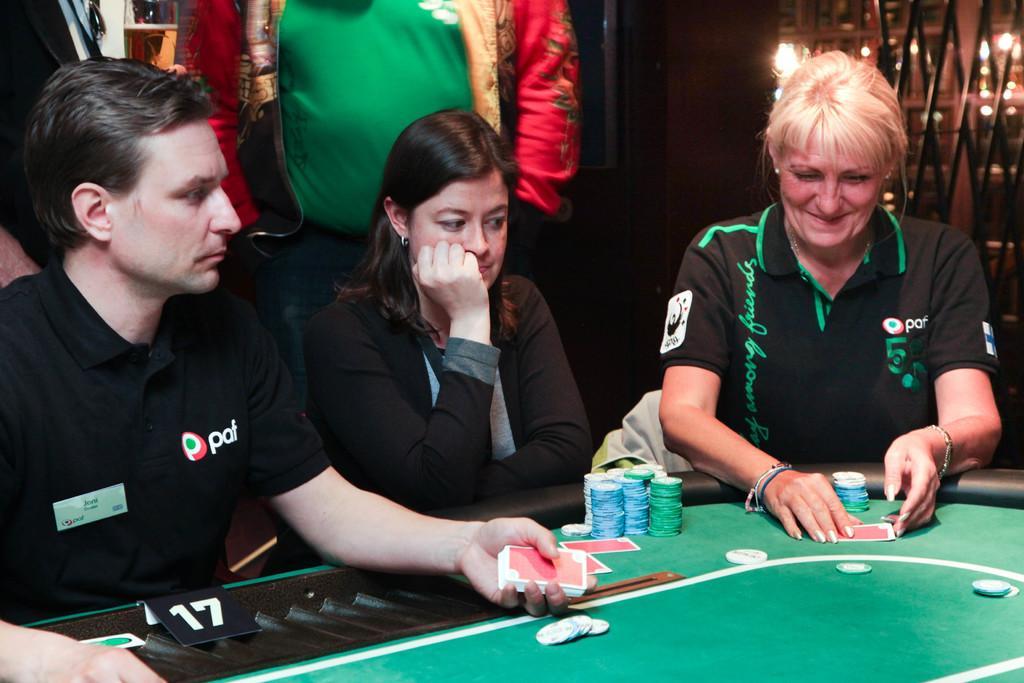In one or two sentences, can you explain what this image depicts? There is a table which has coins and cards on it. There is a man who is holding a cards in his hand. And a woman who is looking at the coins. In the background there is another man who is wearing a jacket and a light on the backside of the men. 